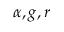Convert formula to latex. <formula><loc_0><loc_0><loc_500><loc_500>\alpha , g , r</formula> 